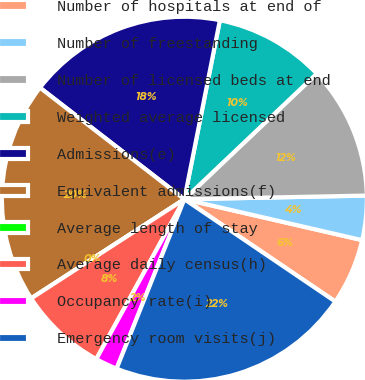Convert chart to OTSL. <chart><loc_0><loc_0><loc_500><loc_500><pie_chart><fcel>Number of hospitals at end of<fcel>Number of freestanding<fcel>Number of licensed beds at end<fcel>Weighted average licensed<fcel>Admissions(e)<fcel>Equivalent admissions(f)<fcel>Average length of stay<fcel>Average daily census(h)<fcel>Occupancy rate(i)<fcel>Emergency room visits(j)<nl><fcel>5.88%<fcel>3.92%<fcel>11.76%<fcel>9.8%<fcel>17.65%<fcel>19.61%<fcel>0.0%<fcel>7.84%<fcel>1.96%<fcel>21.57%<nl></chart> 